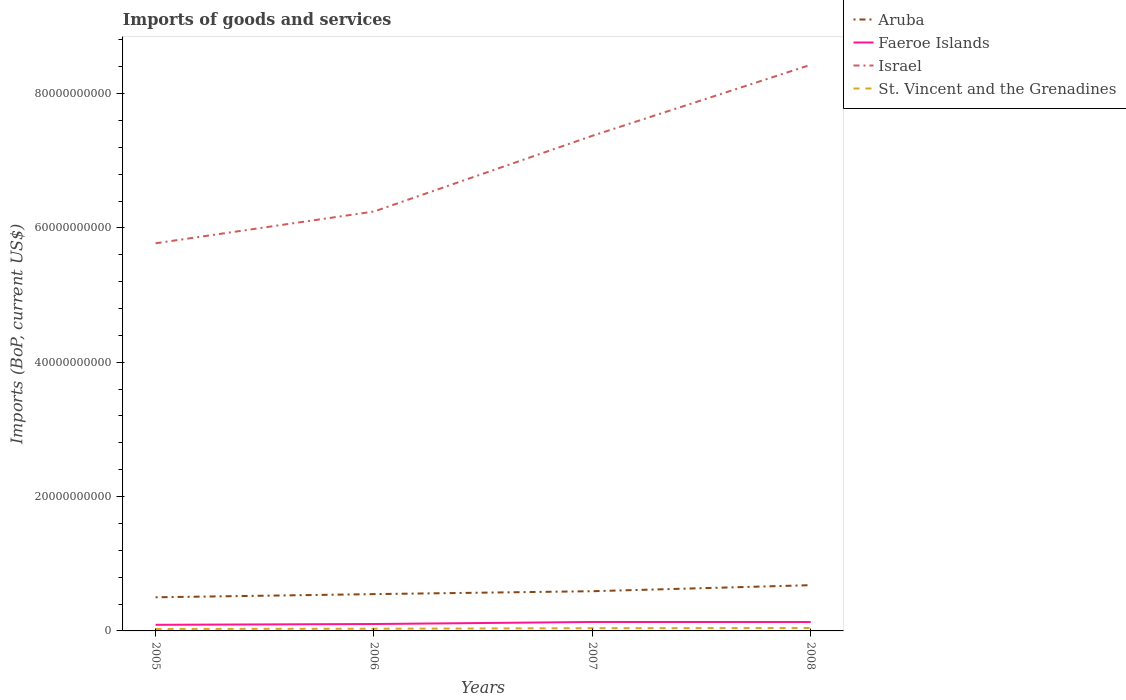How many different coloured lines are there?
Your answer should be compact. 4. Across all years, what is the maximum amount spent on imports in Israel?
Offer a very short reply. 5.77e+1. What is the total amount spent on imports in St. Vincent and the Grenadines in the graph?
Your answer should be compact. -1.05e+08. What is the difference between the highest and the second highest amount spent on imports in Aruba?
Give a very brief answer. 1.80e+09. Is the amount spent on imports in Faeroe Islands strictly greater than the amount spent on imports in Aruba over the years?
Ensure brevity in your answer.  Yes. What is the title of the graph?
Offer a terse response. Imports of goods and services. Does "French Polynesia" appear as one of the legend labels in the graph?
Give a very brief answer. No. What is the label or title of the Y-axis?
Provide a succinct answer. Imports (BoP, current US$). What is the Imports (BoP, current US$) of Aruba in 2005?
Your answer should be very brief. 5.01e+09. What is the Imports (BoP, current US$) in Faeroe Islands in 2005?
Provide a succinct answer. 9.09e+08. What is the Imports (BoP, current US$) in Israel in 2005?
Keep it short and to the point. 5.77e+1. What is the Imports (BoP, current US$) of St. Vincent and the Grenadines in 2005?
Make the answer very short. 2.91e+08. What is the Imports (BoP, current US$) of Aruba in 2006?
Your answer should be compact. 5.48e+09. What is the Imports (BoP, current US$) in Faeroe Islands in 2006?
Offer a terse response. 1.03e+09. What is the Imports (BoP, current US$) of Israel in 2006?
Offer a terse response. 6.24e+1. What is the Imports (BoP, current US$) of St. Vincent and the Grenadines in 2006?
Ensure brevity in your answer.  3.26e+08. What is the Imports (BoP, current US$) of Aruba in 2007?
Provide a short and direct response. 5.91e+09. What is the Imports (BoP, current US$) in Faeroe Islands in 2007?
Offer a terse response. 1.33e+09. What is the Imports (BoP, current US$) of Israel in 2007?
Make the answer very short. 7.37e+1. What is the Imports (BoP, current US$) of St. Vincent and the Grenadines in 2007?
Keep it short and to the point. 4.02e+08. What is the Imports (BoP, current US$) of Aruba in 2008?
Make the answer very short. 6.81e+09. What is the Imports (BoP, current US$) of Faeroe Islands in 2008?
Give a very brief answer. 1.32e+09. What is the Imports (BoP, current US$) in Israel in 2008?
Your answer should be very brief. 8.43e+1. What is the Imports (BoP, current US$) of St. Vincent and the Grenadines in 2008?
Your answer should be very brief. 4.31e+08. Across all years, what is the maximum Imports (BoP, current US$) of Aruba?
Ensure brevity in your answer.  6.81e+09. Across all years, what is the maximum Imports (BoP, current US$) of Faeroe Islands?
Give a very brief answer. 1.33e+09. Across all years, what is the maximum Imports (BoP, current US$) of Israel?
Your answer should be compact. 8.43e+1. Across all years, what is the maximum Imports (BoP, current US$) of St. Vincent and the Grenadines?
Offer a very short reply. 4.31e+08. Across all years, what is the minimum Imports (BoP, current US$) of Aruba?
Your answer should be very brief. 5.01e+09. Across all years, what is the minimum Imports (BoP, current US$) in Faeroe Islands?
Give a very brief answer. 9.09e+08. Across all years, what is the minimum Imports (BoP, current US$) in Israel?
Your answer should be very brief. 5.77e+1. Across all years, what is the minimum Imports (BoP, current US$) in St. Vincent and the Grenadines?
Keep it short and to the point. 2.91e+08. What is the total Imports (BoP, current US$) in Aruba in the graph?
Offer a very short reply. 2.32e+1. What is the total Imports (BoP, current US$) of Faeroe Islands in the graph?
Ensure brevity in your answer.  4.59e+09. What is the total Imports (BoP, current US$) in Israel in the graph?
Offer a very short reply. 2.78e+11. What is the total Imports (BoP, current US$) of St. Vincent and the Grenadines in the graph?
Provide a short and direct response. 1.45e+09. What is the difference between the Imports (BoP, current US$) in Aruba in 2005 and that in 2006?
Provide a succinct answer. -4.72e+08. What is the difference between the Imports (BoP, current US$) of Faeroe Islands in 2005 and that in 2006?
Provide a short and direct response. -1.17e+08. What is the difference between the Imports (BoP, current US$) in Israel in 2005 and that in 2006?
Offer a very short reply. -4.73e+09. What is the difference between the Imports (BoP, current US$) in St. Vincent and the Grenadines in 2005 and that in 2006?
Give a very brief answer. -3.47e+07. What is the difference between the Imports (BoP, current US$) in Aruba in 2005 and that in 2007?
Your answer should be compact. -9.04e+08. What is the difference between the Imports (BoP, current US$) in Faeroe Islands in 2005 and that in 2007?
Offer a terse response. -4.21e+08. What is the difference between the Imports (BoP, current US$) in Israel in 2005 and that in 2007?
Your answer should be very brief. -1.60e+1. What is the difference between the Imports (BoP, current US$) in St. Vincent and the Grenadines in 2005 and that in 2007?
Offer a terse response. -1.11e+08. What is the difference between the Imports (BoP, current US$) in Aruba in 2005 and that in 2008?
Your response must be concise. -1.80e+09. What is the difference between the Imports (BoP, current US$) in Faeroe Islands in 2005 and that in 2008?
Your answer should be compact. -4.15e+08. What is the difference between the Imports (BoP, current US$) in Israel in 2005 and that in 2008?
Your answer should be compact. -2.66e+1. What is the difference between the Imports (BoP, current US$) in St. Vincent and the Grenadines in 2005 and that in 2008?
Your answer should be very brief. -1.40e+08. What is the difference between the Imports (BoP, current US$) in Aruba in 2006 and that in 2007?
Ensure brevity in your answer.  -4.32e+08. What is the difference between the Imports (BoP, current US$) of Faeroe Islands in 2006 and that in 2007?
Your response must be concise. -3.04e+08. What is the difference between the Imports (BoP, current US$) of Israel in 2006 and that in 2007?
Provide a short and direct response. -1.13e+1. What is the difference between the Imports (BoP, current US$) in St. Vincent and the Grenadines in 2006 and that in 2007?
Offer a very short reply. -7.63e+07. What is the difference between the Imports (BoP, current US$) in Aruba in 2006 and that in 2008?
Offer a terse response. -1.33e+09. What is the difference between the Imports (BoP, current US$) of Faeroe Islands in 2006 and that in 2008?
Keep it short and to the point. -2.98e+08. What is the difference between the Imports (BoP, current US$) of Israel in 2006 and that in 2008?
Offer a very short reply. -2.18e+1. What is the difference between the Imports (BoP, current US$) in St. Vincent and the Grenadines in 2006 and that in 2008?
Your response must be concise. -1.05e+08. What is the difference between the Imports (BoP, current US$) in Aruba in 2007 and that in 2008?
Your answer should be very brief. -9.00e+08. What is the difference between the Imports (BoP, current US$) in Faeroe Islands in 2007 and that in 2008?
Ensure brevity in your answer.  6.06e+06. What is the difference between the Imports (BoP, current US$) in Israel in 2007 and that in 2008?
Offer a terse response. -1.06e+1. What is the difference between the Imports (BoP, current US$) of St. Vincent and the Grenadines in 2007 and that in 2008?
Offer a terse response. -2.87e+07. What is the difference between the Imports (BoP, current US$) of Aruba in 2005 and the Imports (BoP, current US$) of Faeroe Islands in 2006?
Provide a succinct answer. 3.98e+09. What is the difference between the Imports (BoP, current US$) in Aruba in 2005 and the Imports (BoP, current US$) in Israel in 2006?
Offer a very short reply. -5.74e+1. What is the difference between the Imports (BoP, current US$) in Aruba in 2005 and the Imports (BoP, current US$) in St. Vincent and the Grenadines in 2006?
Give a very brief answer. 4.68e+09. What is the difference between the Imports (BoP, current US$) in Faeroe Islands in 2005 and the Imports (BoP, current US$) in Israel in 2006?
Provide a short and direct response. -6.15e+1. What is the difference between the Imports (BoP, current US$) of Faeroe Islands in 2005 and the Imports (BoP, current US$) of St. Vincent and the Grenadines in 2006?
Offer a very short reply. 5.83e+08. What is the difference between the Imports (BoP, current US$) in Israel in 2005 and the Imports (BoP, current US$) in St. Vincent and the Grenadines in 2006?
Provide a short and direct response. 5.74e+1. What is the difference between the Imports (BoP, current US$) in Aruba in 2005 and the Imports (BoP, current US$) in Faeroe Islands in 2007?
Your response must be concise. 3.68e+09. What is the difference between the Imports (BoP, current US$) in Aruba in 2005 and the Imports (BoP, current US$) in Israel in 2007?
Keep it short and to the point. -6.87e+1. What is the difference between the Imports (BoP, current US$) of Aruba in 2005 and the Imports (BoP, current US$) of St. Vincent and the Grenadines in 2007?
Ensure brevity in your answer.  4.61e+09. What is the difference between the Imports (BoP, current US$) of Faeroe Islands in 2005 and the Imports (BoP, current US$) of Israel in 2007?
Provide a short and direct response. -7.28e+1. What is the difference between the Imports (BoP, current US$) of Faeroe Islands in 2005 and the Imports (BoP, current US$) of St. Vincent and the Grenadines in 2007?
Offer a very short reply. 5.07e+08. What is the difference between the Imports (BoP, current US$) of Israel in 2005 and the Imports (BoP, current US$) of St. Vincent and the Grenadines in 2007?
Provide a succinct answer. 5.73e+1. What is the difference between the Imports (BoP, current US$) in Aruba in 2005 and the Imports (BoP, current US$) in Faeroe Islands in 2008?
Your answer should be compact. 3.68e+09. What is the difference between the Imports (BoP, current US$) in Aruba in 2005 and the Imports (BoP, current US$) in Israel in 2008?
Give a very brief answer. -7.93e+1. What is the difference between the Imports (BoP, current US$) in Aruba in 2005 and the Imports (BoP, current US$) in St. Vincent and the Grenadines in 2008?
Keep it short and to the point. 4.58e+09. What is the difference between the Imports (BoP, current US$) in Faeroe Islands in 2005 and the Imports (BoP, current US$) in Israel in 2008?
Offer a very short reply. -8.34e+1. What is the difference between the Imports (BoP, current US$) of Faeroe Islands in 2005 and the Imports (BoP, current US$) of St. Vincent and the Grenadines in 2008?
Provide a short and direct response. 4.78e+08. What is the difference between the Imports (BoP, current US$) of Israel in 2005 and the Imports (BoP, current US$) of St. Vincent and the Grenadines in 2008?
Offer a very short reply. 5.73e+1. What is the difference between the Imports (BoP, current US$) of Aruba in 2006 and the Imports (BoP, current US$) of Faeroe Islands in 2007?
Your response must be concise. 4.15e+09. What is the difference between the Imports (BoP, current US$) of Aruba in 2006 and the Imports (BoP, current US$) of Israel in 2007?
Keep it short and to the point. -6.82e+1. What is the difference between the Imports (BoP, current US$) in Aruba in 2006 and the Imports (BoP, current US$) in St. Vincent and the Grenadines in 2007?
Your response must be concise. 5.08e+09. What is the difference between the Imports (BoP, current US$) of Faeroe Islands in 2006 and the Imports (BoP, current US$) of Israel in 2007?
Make the answer very short. -7.27e+1. What is the difference between the Imports (BoP, current US$) of Faeroe Islands in 2006 and the Imports (BoP, current US$) of St. Vincent and the Grenadines in 2007?
Make the answer very short. 6.23e+08. What is the difference between the Imports (BoP, current US$) of Israel in 2006 and the Imports (BoP, current US$) of St. Vincent and the Grenadines in 2007?
Your response must be concise. 6.20e+1. What is the difference between the Imports (BoP, current US$) of Aruba in 2006 and the Imports (BoP, current US$) of Faeroe Islands in 2008?
Keep it short and to the point. 4.16e+09. What is the difference between the Imports (BoP, current US$) of Aruba in 2006 and the Imports (BoP, current US$) of Israel in 2008?
Provide a succinct answer. -7.88e+1. What is the difference between the Imports (BoP, current US$) of Aruba in 2006 and the Imports (BoP, current US$) of St. Vincent and the Grenadines in 2008?
Ensure brevity in your answer.  5.05e+09. What is the difference between the Imports (BoP, current US$) of Faeroe Islands in 2006 and the Imports (BoP, current US$) of Israel in 2008?
Ensure brevity in your answer.  -8.33e+1. What is the difference between the Imports (BoP, current US$) of Faeroe Islands in 2006 and the Imports (BoP, current US$) of St. Vincent and the Grenadines in 2008?
Your answer should be compact. 5.95e+08. What is the difference between the Imports (BoP, current US$) of Israel in 2006 and the Imports (BoP, current US$) of St. Vincent and the Grenadines in 2008?
Give a very brief answer. 6.20e+1. What is the difference between the Imports (BoP, current US$) of Aruba in 2007 and the Imports (BoP, current US$) of Faeroe Islands in 2008?
Your answer should be very brief. 4.59e+09. What is the difference between the Imports (BoP, current US$) in Aruba in 2007 and the Imports (BoP, current US$) in Israel in 2008?
Give a very brief answer. -7.84e+1. What is the difference between the Imports (BoP, current US$) of Aruba in 2007 and the Imports (BoP, current US$) of St. Vincent and the Grenadines in 2008?
Your answer should be very brief. 5.48e+09. What is the difference between the Imports (BoP, current US$) in Faeroe Islands in 2007 and the Imports (BoP, current US$) in Israel in 2008?
Ensure brevity in your answer.  -8.30e+1. What is the difference between the Imports (BoP, current US$) of Faeroe Islands in 2007 and the Imports (BoP, current US$) of St. Vincent and the Grenadines in 2008?
Offer a terse response. 8.99e+08. What is the difference between the Imports (BoP, current US$) in Israel in 2007 and the Imports (BoP, current US$) in St. Vincent and the Grenadines in 2008?
Offer a terse response. 7.33e+1. What is the average Imports (BoP, current US$) of Aruba per year?
Ensure brevity in your answer.  5.80e+09. What is the average Imports (BoP, current US$) in Faeroe Islands per year?
Give a very brief answer. 1.15e+09. What is the average Imports (BoP, current US$) of Israel per year?
Provide a succinct answer. 6.95e+1. What is the average Imports (BoP, current US$) in St. Vincent and the Grenadines per year?
Your answer should be compact. 3.62e+08. In the year 2005, what is the difference between the Imports (BoP, current US$) in Aruba and Imports (BoP, current US$) in Faeroe Islands?
Give a very brief answer. 4.10e+09. In the year 2005, what is the difference between the Imports (BoP, current US$) in Aruba and Imports (BoP, current US$) in Israel?
Your answer should be compact. -5.27e+1. In the year 2005, what is the difference between the Imports (BoP, current US$) of Aruba and Imports (BoP, current US$) of St. Vincent and the Grenadines?
Your answer should be very brief. 4.72e+09. In the year 2005, what is the difference between the Imports (BoP, current US$) of Faeroe Islands and Imports (BoP, current US$) of Israel?
Provide a short and direct response. -5.68e+1. In the year 2005, what is the difference between the Imports (BoP, current US$) in Faeroe Islands and Imports (BoP, current US$) in St. Vincent and the Grenadines?
Give a very brief answer. 6.17e+08. In the year 2005, what is the difference between the Imports (BoP, current US$) in Israel and Imports (BoP, current US$) in St. Vincent and the Grenadines?
Provide a succinct answer. 5.74e+1. In the year 2006, what is the difference between the Imports (BoP, current US$) in Aruba and Imports (BoP, current US$) in Faeroe Islands?
Offer a terse response. 4.45e+09. In the year 2006, what is the difference between the Imports (BoP, current US$) in Aruba and Imports (BoP, current US$) in Israel?
Offer a very short reply. -5.70e+1. In the year 2006, what is the difference between the Imports (BoP, current US$) in Aruba and Imports (BoP, current US$) in St. Vincent and the Grenadines?
Your response must be concise. 5.15e+09. In the year 2006, what is the difference between the Imports (BoP, current US$) of Faeroe Islands and Imports (BoP, current US$) of Israel?
Keep it short and to the point. -6.14e+1. In the year 2006, what is the difference between the Imports (BoP, current US$) of Faeroe Islands and Imports (BoP, current US$) of St. Vincent and the Grenadines?
Provide a short and direct response. 7.00e+08. In the year 2006, what is the difference between the Imports (BoP, current US$) of Israel and Imports (BoP, current US$) of St. Vincent and the Grenadines?
Your answer should be compact. 6.21e+1. In the year 2007, what is the difference between the Imports (BoP, current US$) of Aruba and Imports (BoP, current US$) of Faeroe Islands?
Your answer should be compact. 4.58e+09. In the year 2007, what is the difference between the Imports (BoP, current US$) of Aruba and Imports (BoP, current US$) of Israel?
Provide a short and direct response. -6.78e+1. In the year 2007, what is the difference between the Imports (BoP, current US$) in Aruba and Imports (BoP, current US$) in St. Vincent and the Grenadines?
Make the answer very short. 5.51e+09. In the year 2007, what is the difference between the Imports (BoP, current US$) in Faeroe Islands and Imports (BoP, current US$) in Israel?
Give a very brief answer. -7.24e+1. In the year 2007, what is the difference between the Imports (BoP, current US$) of Faeroe Islands and Imports (BoP, current US$) of St. Vincent and the Grenadines?
Provide a short and direct response. 9.28e+08. In the year 2007, what is the difference between the Imports (BoP, current US$) in Israel and Imports (BoP, current US$) in St. Vincent and the Grenadines?
Your answer should be compact. 7.33e+1. In the year 2008, what is the difference between the Imports (BoP, current US$) in Aruba and Imports (BoP, current US$) in Faeroe Islands?
Your answer should be compact. 5.49e+09. In the year 2008, what is the difference between the Imports (BoP, current US$) of Aruba and Imports (BoP, current US$) of Israel?
Keep it short and to the point. -7.75e+1. In the year 2008, what is the difference between the Imports (BoP, current US$) in Aruba and Imports (BoP, current US$) in St. Vincent and the Grenadines?
Offer a very short reply. 6.38e+09. In the year 2008, what is the difference between the Imports (BoP, current US$) in Faeroe Islands and Imports (BoP, current US$) in Israel?
Offer a terse response. -8.30e+1. In the year 2008, what is the difference between the Imports (BoP, current US$) in Faeroe Islands and Imports (BoP, current US$) in St. Vincent and the Grenadines?
Offer a terse response. 8.93e+08. In the year 2008, what is the difference between the Imports (BoP, current US$) in Israel and Imports (BoP, current US$) in St. Vincent and the Grenadines?
Your answer should be compact. 8.39e+1. What is the ratio of the Imports (BoP, current US$) in Aruba in 2005 to that in 2006?
Your response must be concise. 0.91. What is the ratio of the Imports (BoP, current US$) in Faeroe Islands in 2005 to that in 2006?
Offer a very short reply. 0.89. What is the ratio of the Imports (BoP, current US$) in Israel in 2005 to that in 2006?
Provide a succinct answer. 0.92. What is the ratio of the Imports (BoP, current US$) of St. Vincent and the Grenadines in 2005 to that in 2006?
Keep it short and to the point. 0.89. What is the ratio of the Imports (BoP, current US$) of Aruba in 2005 to that in 2007?
Make the answer very short. 0.85. What is the ratio of the Imports (BoP, current US$) in Faeroe Islands in 2005 to that in 2007?
Make the answer very short. 0.68. What is the ratio of the Imports (BoP, current US$) in Israel in 2005 to that in 2007?
Offer a terse response. 0.78. What is the ratio of the Imports (BoP, current US$) in St. Vincent and the Grenadines in 2005 to that in 2007?
Offer a terse response. 0.72. What is the ratio of the Imports (BoP, current US$) of Aruba in 2005 to that in 2008?
Make the answer very short. 0.74. What is the ratio of the Imports (BoP, current US$) of Faeroe Islands in 2005 to that in 2008?
Your answer should be compact. 0.69. What is the ratio of the Imports (BoP, current US$) of Israel in 2005 to that in 2008?
Your answer should be compact. 0.68. What is the ratio of the Imports (BoP, current US$) in St. Vincent and the Grenadines in 2005 to that in 2008?
Your response must be concise. 0.68. What is the ratio of the Imports (BoP, current US$) in Aruba in 2006 to that in 2007?
Offer a terse response. 0.93. What is the ratio of the Imports (BoP, current US$) of Faeroe Islands in 2006 to that in 2007?
Make the answer very short. 0.77. What is the ratio of the Imports (BoP, current US$) in Israel in 2006 to that in 2007?
Your answer should be very brief. 0.85. What is the ratio of the Imports (BoP, current US$) of St. Vincent and the Grenadines in 2006 to that in 2007?
Ensure brevity in your answer.  0.81. What is the ratio of the Imports (BoP, current US$) of Aruba in 2006 to that in 2008?
Keep it short and to the point. 0.8. What is the ratio of the Imports (BoP, current US$) of Faeroe Islands in 2006 to that in 2008?
Offer a very short reply. 0.77. What is the ratio of the Imports (BoP, current US$) of Israel in 2006 to that in 2008?
Keep it short and to the point. 0.74. What is the ratio of the Imports (BoP, current US$) of St. Vincent and the Grenadines in 2006 to that in 2008?
Keep it short and to the point. 0.76. What is the ratio of the Imports (BoP, current US$) of Aruba in 2007 to that in 2008?
Make the answer very short. 0.87. What is the ratio of the Imports (BoP, current US$) of Faeroe Islands in 2007 to that in 2008?
Make the answer very short. 1. What is the ratio of the Imports (BoP, current US$) in Israel in 2007 to that in 2008?
Ensure brevity in your answer.  0.87. What is the ratio of the Imports (BoP, current US$) in St. Vincent and the Grenadines in 2007 to that in 2008?
Keep it short and to the point. 0.93. What is the difference between the highest and the second highest Imports (BoP, current US$) of Aruba?
Offer a terse response. 9.00e+08. What is the difference between the highest and the second highest Imports (BoP, current US$) in Faeroe Islands?
Give a very brief answer. 6.06e+06. What is the difference between the highest and the second highest Imports (BoP, current US$) in Israel?
Your answer should be very brief. 1.06e+1. What is the difference between the highest and the second highest Imports (BoP, current US$) of St. Vincent and the Grenadines?
Your answer should be compact. 2.87e+07. What is the difference between the highest and the lowest Imports (BoP, current US$) of Aruba?
Ensure brevity in your answer.  1.80e+09. What is the difference between the highest and the lowest Imports (BoP, current US$) in Faeroe Islands?
Your answer should be compact. 4.21e+08. What is the difference between the highest and the lowest Imports (BoP, current US$) of Israel?
Ensure brevity in your answer.  2.66e+1. What is the difference between the highest and the lowest Imports (BoP, current US$) of St. Vincent and the Grenadines?
Ensure brevity in your answer.  1.40e+08. 